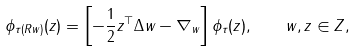Convert formula to latex. <formula><loc_0><loc_0><loc_500><loc_500>\phi _ { \tau ( R w ) } ( z ) = \left [ - \frac { 1 } { 2 } z ^ { \top } \Delta w - \nabla _ { w } \right ] \phi _ { \tau } ( z ) , \quad w , z \in Z ,</formula> 